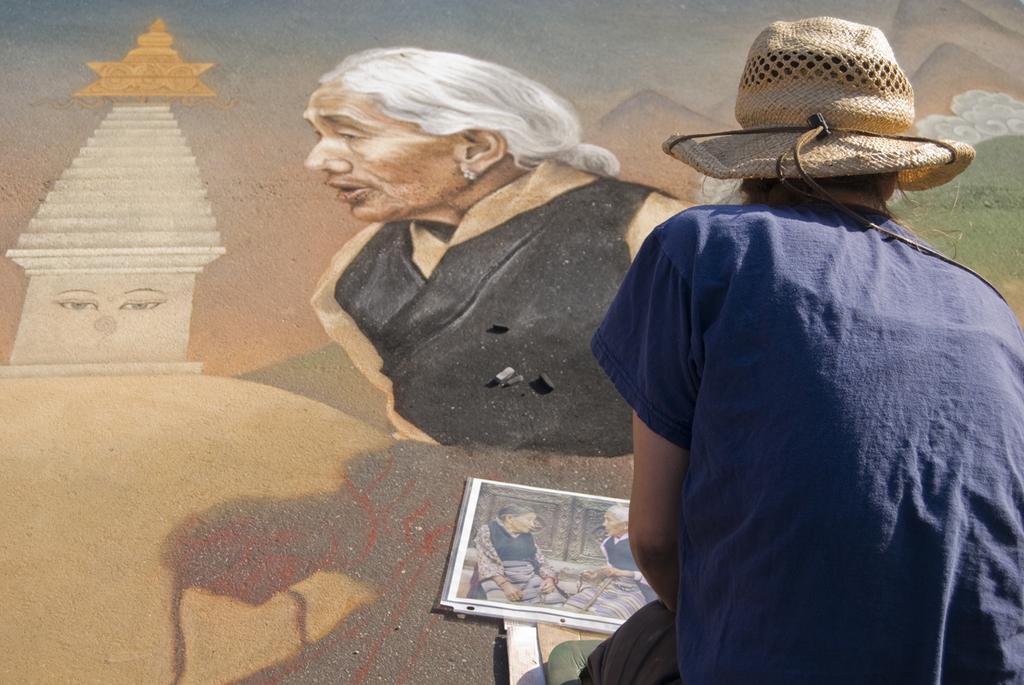Could you give a brief overview of what you see in this image? In this image I can see one person in the front. I can see this person is wearing a hat and the blue dress. On the bottom side of the image I can see a photo of two persons. On the top side of the image I can see the painting of a woman and few other things. 